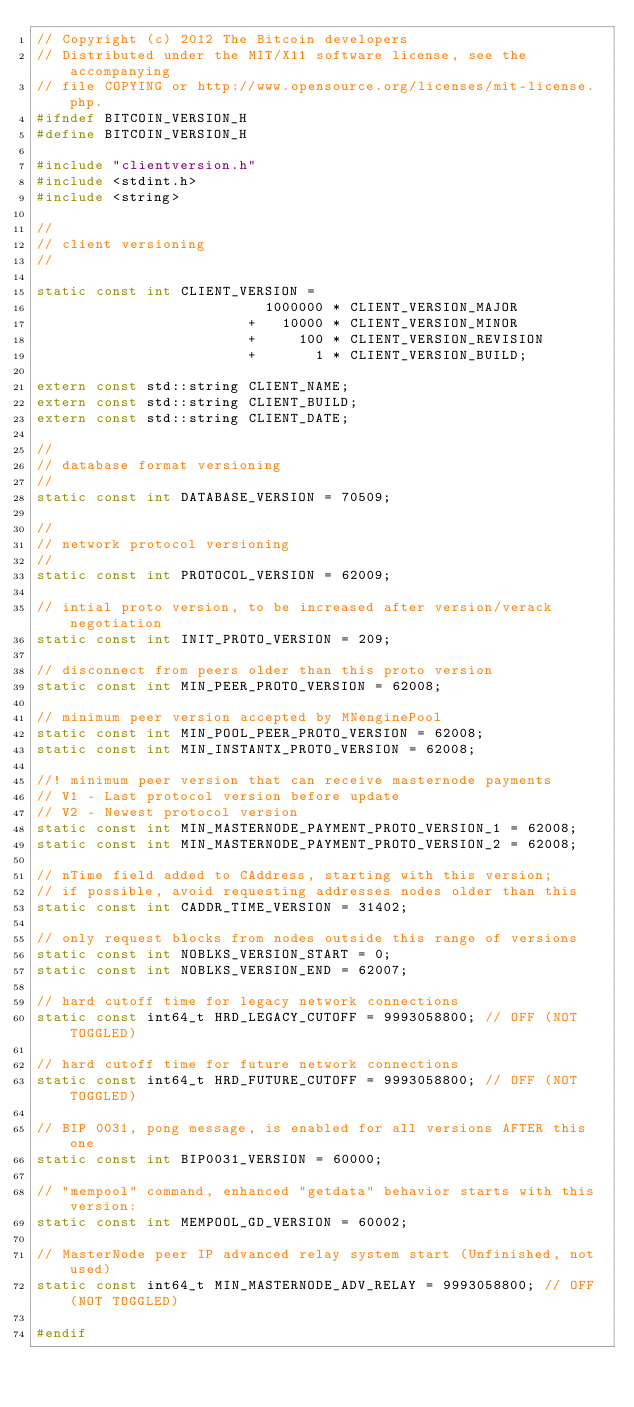<code> <loc_0><loc_0><loc_500><loc_500><_C_>// Copyright (c) 2012 The Bitcoin developers
// Distributed under the MIT/X11 software license, see the accompanying
// file COPYING or http://www.opensource.org/licenses/mit-license.php.
#ifndef BITCOIN_VERSION_H
#define BITCOIN_VERSION_H

#include "clientversion.h"
#include <stdint.h>
#include <string>

//
// client versioning
//

static const int CLIENT_VERSION =
                           1000000 * CLIENT_VERSION_MAJOR
                         +   10000 * CLIENT_VERSION_MINOR
                         +     100 * CLIENT_VERSION_REVISION
                         +       1 * CLIENT_VERSION_BUILD;

extern const std::string CLIENT_NAME;
extern const std::string CLIENT_BUILD;
extern const std::string CLIENT_DATE;

//
// database format versioning
//
static const int DATABASE_VERSION = 70509;

//
// network protocol versioning
//
static const int PROTOCOL_VERSION = 62009;

// intial proto version, to be increased after version/verack negotiation
static const int INIT_PROTO_VERSION = 209;

// disconnect from peers older than this proto version
static const int MIN_PEER_PROTO_VERSION = 62008;

// minimum peer version accepted by MNenginePool
static const int MIN_POOL_PEER_PROTO_VERSION = 62008;
static const int MIN_INSTANTX_PROTO_VERSION = 62008;

//! minimum peer version that can receive masternode payments
// V1 - Last protocol version before update
// V2 - Newest protocol version
static const int MIN_MASTERNODE_PAYMENT_PROTO_VERSION_1 = 62008;
static const int MIN_MASTERNODE_PAYMENT_PROTO_VERSION_2 = 62008;

// nTime field added to CAddress, starting with this version;
// if possible, avoid requesting addresses nodes older than this
static const int CADDR_TIME_VERSION = 31402;

// only request blocks from nodes outside this range of versions
static const int NOBLKS_VERSION_START = 0;
static const int NOBLKS_VERSION_END = 62007;

// hard cutoff time for legacy network connections
static const int64_t HRD_LEGACY_CUTOFF = 9993058800; // OFF (NOT TOGGLED)

// hard cutoff time for future network connections
static const int64_t HRD_FUTURE_CUTOFF = 9993058800; // OFF (NOT TOGGLED)

// BIP 0031, pong message, is enabled for all versions AFTER this one
static const int BIP0031_VERSION = 60000;

// "mempool" command, enhanced "getdata" behavior starts with this version:
static const int MEMPOOL_GD_VERSION = 60002;

// MasterNode peer IP advanced relay system start (Unfinished, not used)
static const int64_t MIN_MASTERNODE_ADV_RELAY = 9993058800; // OFF (NOT TOGGLED)

#endif
</code> 